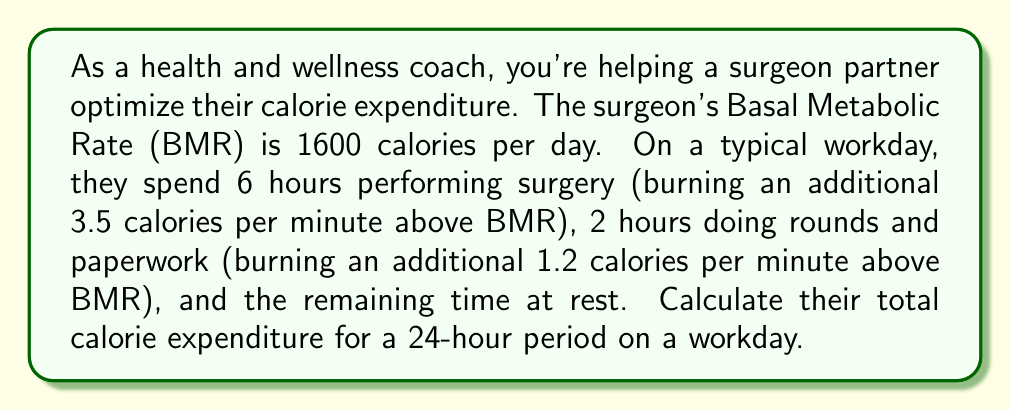Give your solution to this math problem. Let's break this down step-by-step:

1) First, calculate the BMR calories for 24 hours:
   $$ \text{BMR calories} = 1600 \text{ calories} $$

2) Calculate calories burned during surgery:
   $$ \text{Surgery calories} = 6 \text{ hours} \times 60 \text{ min/hour} \times 3.5 \text{ cal/min} = 1260 \text{ calories} $$

3) Calculate calories burned during rounds and paperwork:
   $$ \text{Rounds calories} = 2 \text{ hours} \times 60 \text{ min/hour} \times 1.2 \text{ cal/min} = 144 \text{ calories} $$

4) Calculate the remaining time at rest:
   $$ \text{Rest time} = 24 \text{ hours} - 6 \text{ hours} - 2 \text{ hours} = 16 \text{ hours} $$

5) During rest time, they burn calories at their BMR rate. We've already accounted for this in step 1.

6) Sum up all the calories:
   $$ \text{Total calories} = \text{BMR calories} + \text{Surgery calories} + \text{Rounds calories} $$
   $$ \text{Total calories} = 1600 + 1260 + 144 = 3004 \text{ calories} $$

Therefore, the surgeon's total calorie expenditure for a 24-hour period on a workday is 3004 calories.
Answer: 3004 calories 